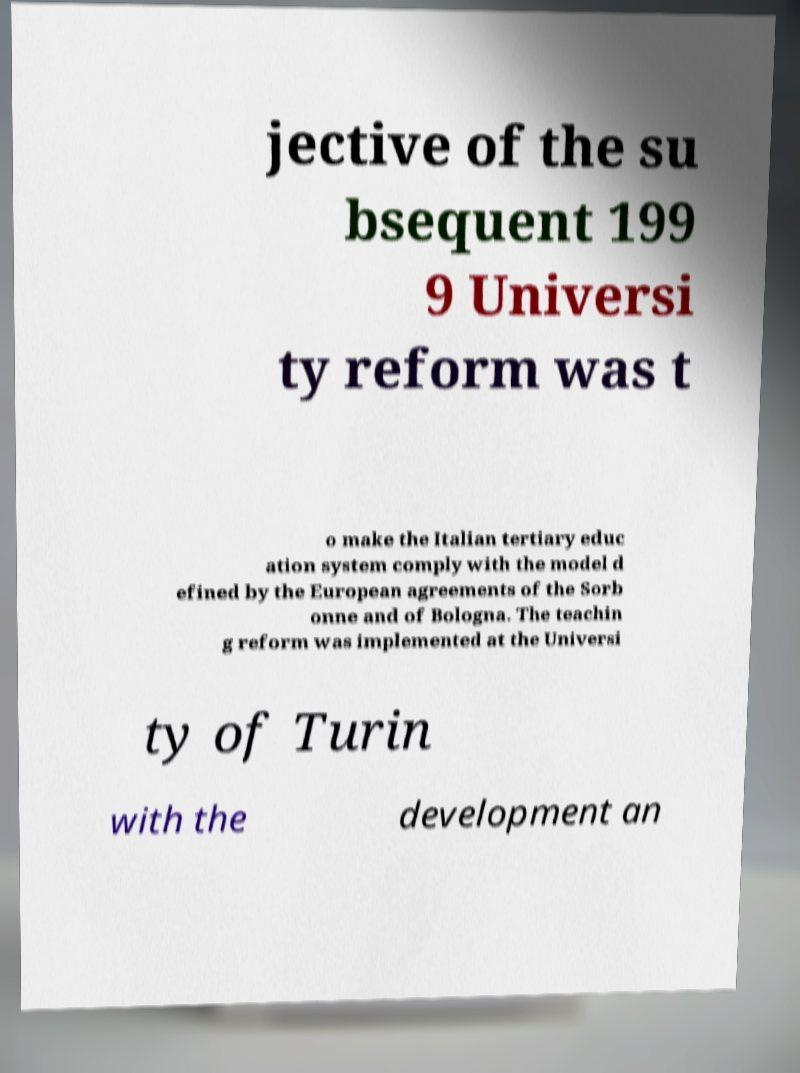What messages or text are displayed in this image? I need them in a readable, typed format. jective of the su bsequent 199 9 Universi ty reform was t o make the Italian tertiary educ ation system comply with the model d efined by the European agreements of the Sorb onne and of Bologna. The teachin g reform was implemented at the Universi ty of Turin with the development an 